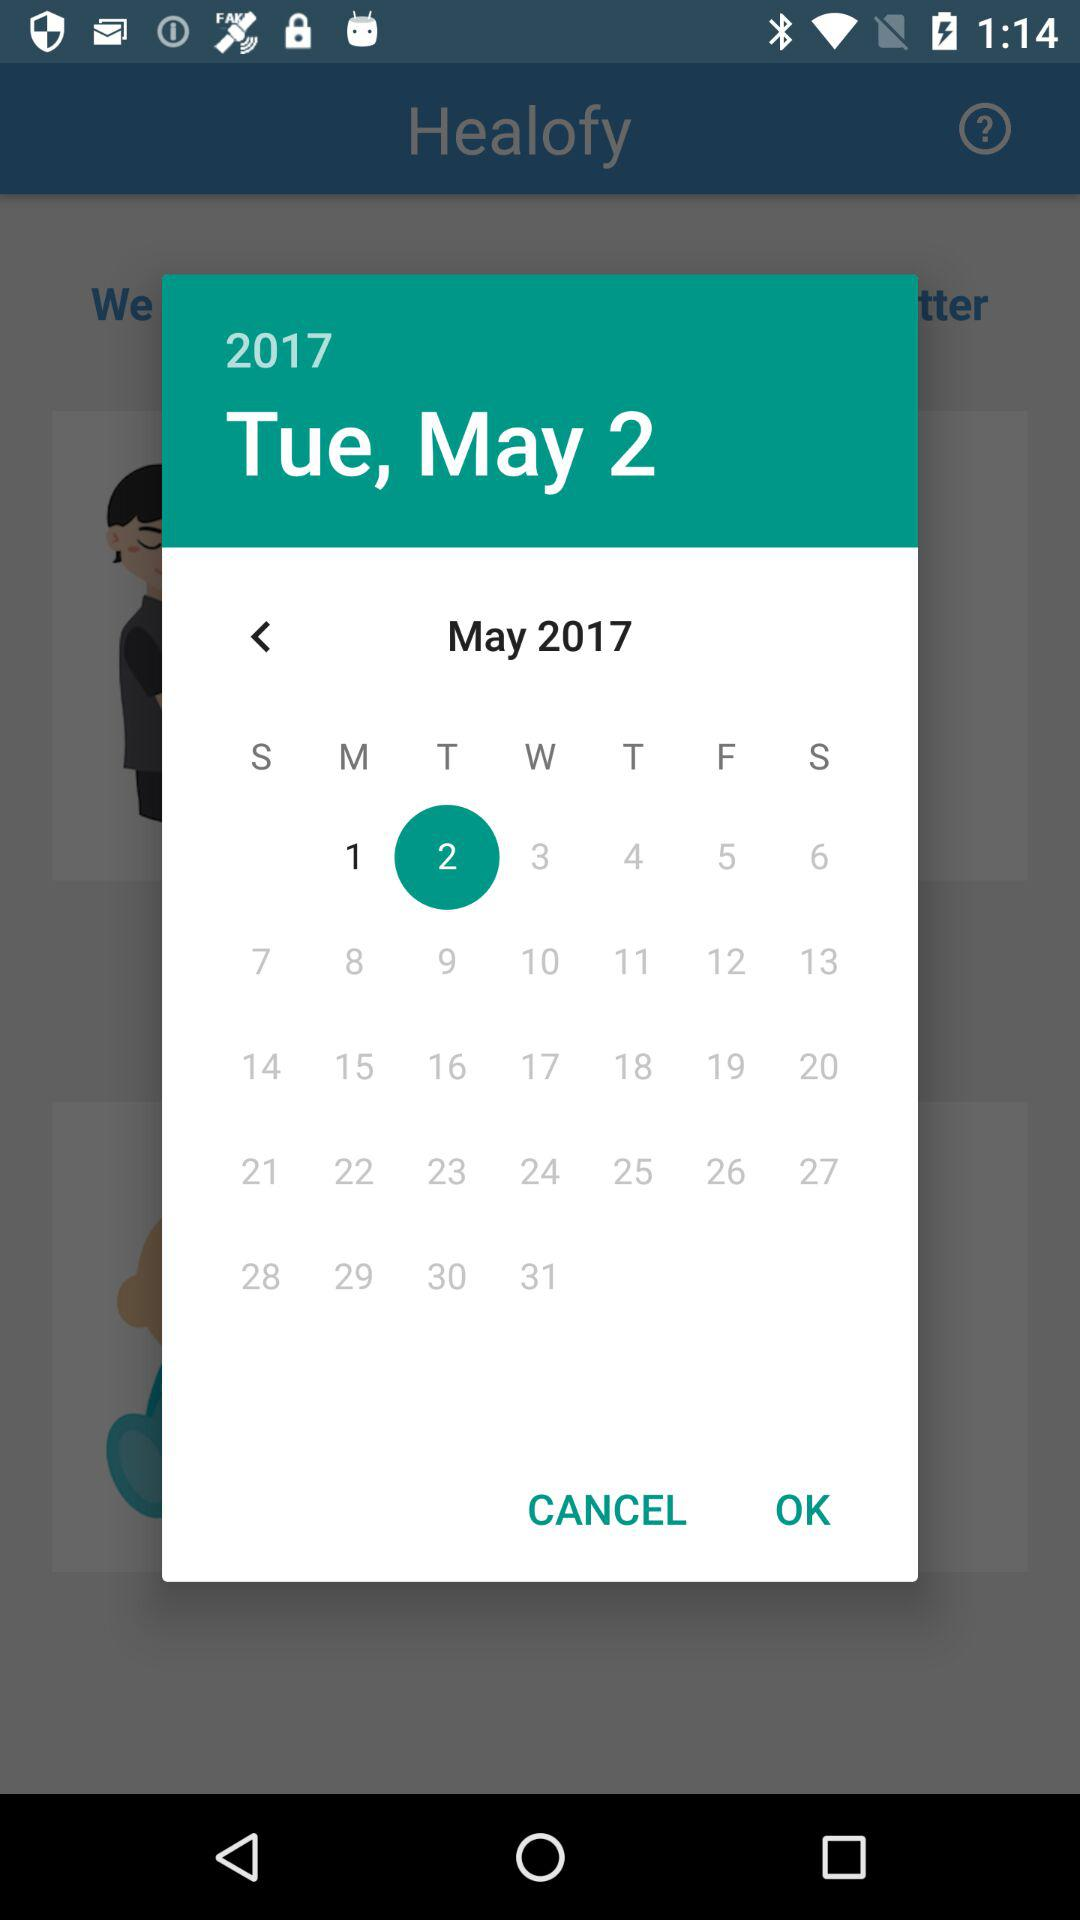How many months are between the 2nd of May and the 31st of May?
Answer the question using a single word or phrase. 1 